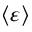Convert formula to latex. <formula><loc_0><loc_0><loc_500><loc_500>\left \langle \varepsilon \right \rangle</formula> 